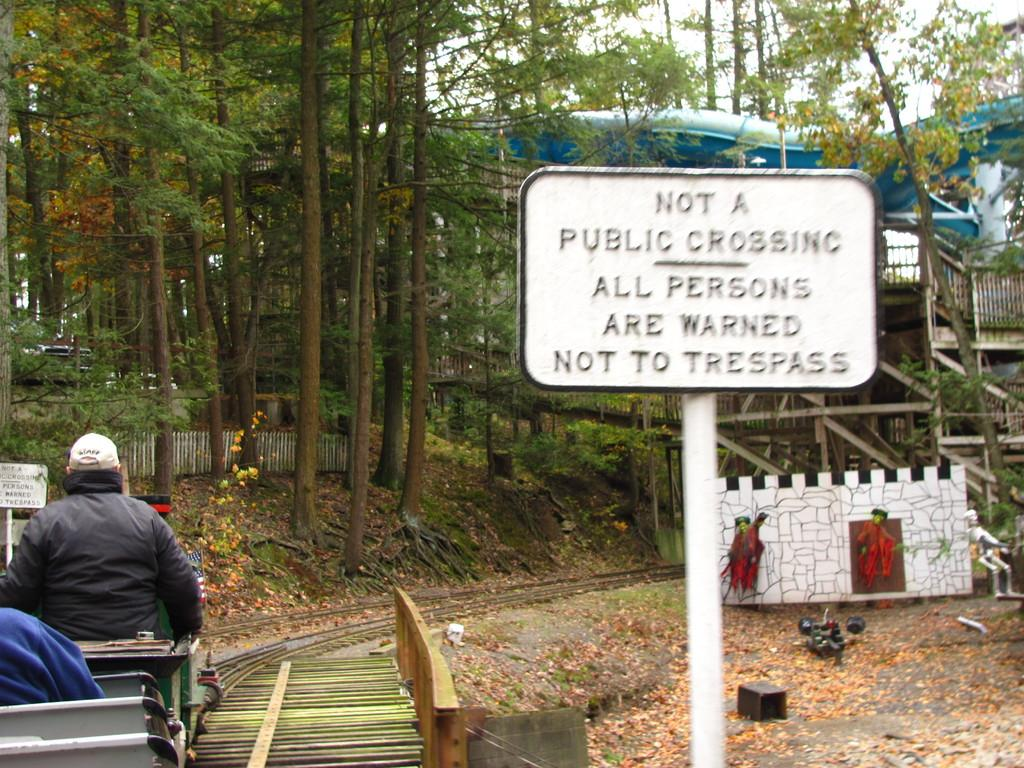What is the color of the sign board in the image? The sign board in the image is white. What is the man in the image doing? The man is sitting on the left side of the image. What can be seen in the background of the image? There are green trees in the background of the image. Is the man playing a game with the plough in the image? There is no plough or indication of a game in the image; the man is simply sitting on the left side. Can you see a swing in the image? There is no swing present in the image. 